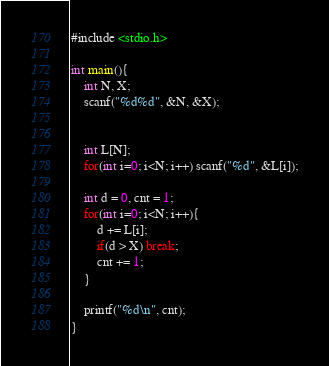Convert code to text. <code><loc_0><loc_0><loc_500><loc_500><_C_>#include <stdio.h>

int main(){
	int N, X;
	scanf("%d%d", &N, &X);


	int L[N];
	for(int i=0; i<N; i++) scanf("%d", &L[i]);

	int d = 0, cnt = 1;
	for(int i=0; i<N; i++){
		d += L[i];
		if(d > X) break;
		cnt += 1;
	}

	printf("%d\n", cnt);
}</code> 